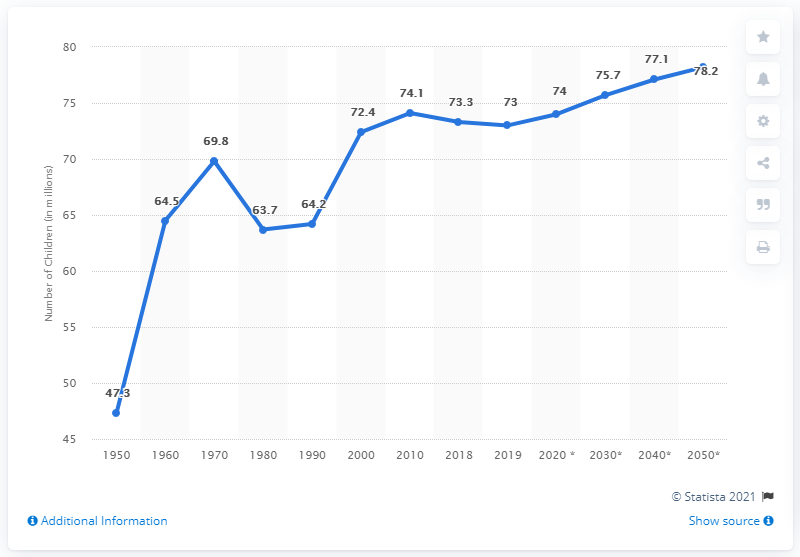Give some essential details in this illustration. In 2018, there were approximately 74 million children in the United States. The estimated number of children in the United States in 2050 is projected to be 78.2 million. In 2019, there were approximately 73 million children living in the United States. 